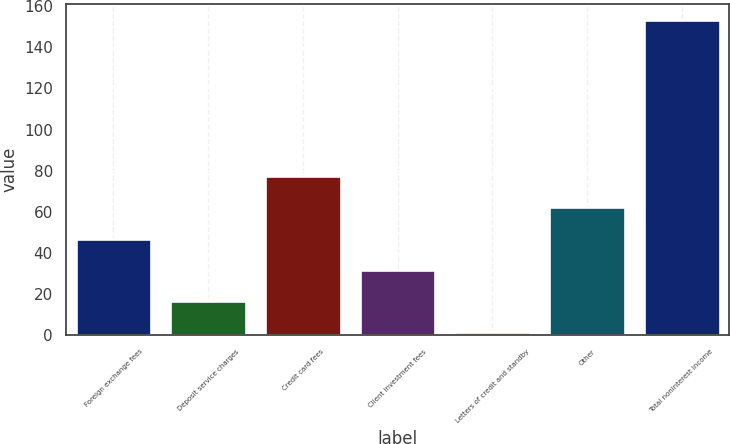Convert chart to OTSL. <chart><loc_0><loc_0><loc_500><loc_500><bar_chart><fcel>Foreign exchange fees<fcel>Deposit service charges<fcel>Credit card fees<fcel>Client investment fees<fcel>Letters of credit and standby<fcel>Other<fcel>Total noninterest income<nl><fcel>46.94<fcel>16.58<fcel>77.3<fcel>31.76<fcel>1.4<fcel>62.12<fcel>153.2<nl></chart> 